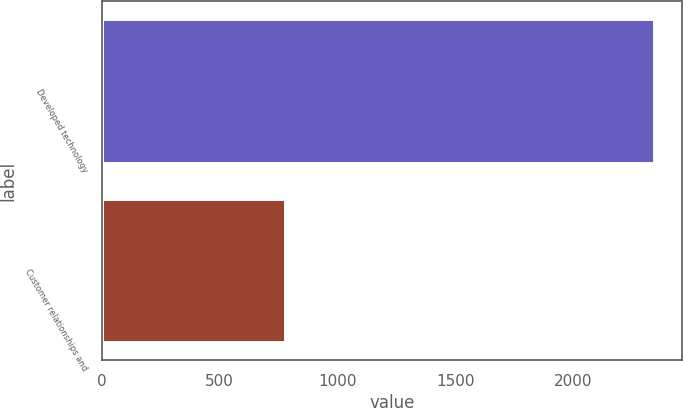<chart> <loc_0><loc_0><loc_500><loc_500><bar_chart><fcel>Developed technology<fcel>Customer relationships and<nl><fcel>2346<fcel>777<nl></chart> 